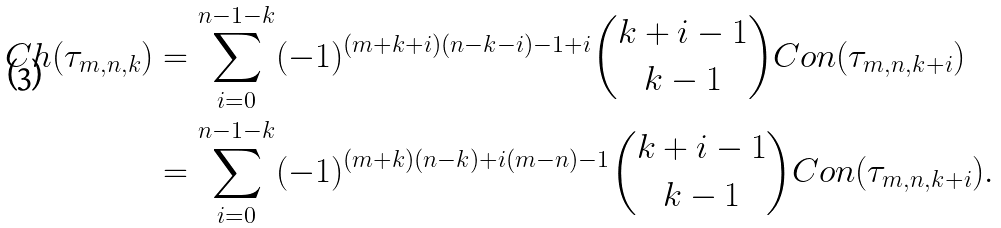<formula> <loc_0><loc_0><loc_500><loc_500>C h ( \tau _ { m , n , k } ) & = \sum _ { i = 0 } ^ { n - 1 - k } ( - 1 ) ^ { ( m + k + i ) ( n - k - i ) - 1 + i } \binom { k + i - 1 } { k - 1 } C o n ( \tau _ { m , n , k + i } ) \\ & = \sum _ { i = 0 } ^ { n - 1 - k } ( - 1 ) ^ { ( m + k ) ( n - k ) + i ( m - n ) - 1 } \binom { k + i - 1 } { k - 1 } C o n ( \tau _ { m , n , k + i } ) .</formula> 